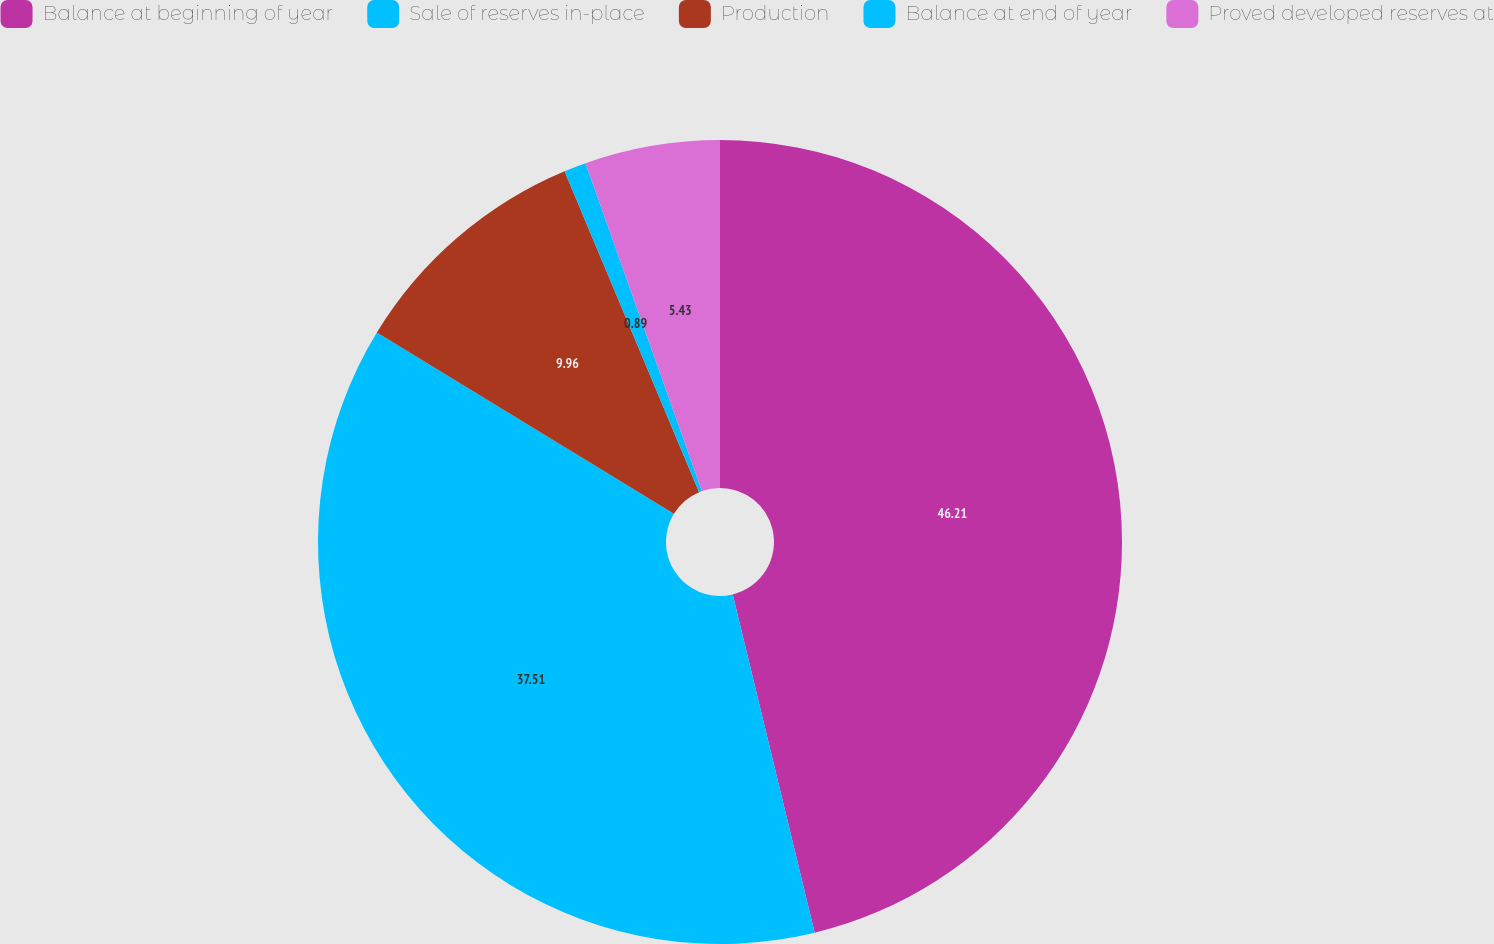Convert chart to OTSL. <chart><loc_0><loc_0><loc_500><loc_500><pie_chart><fcel>Balance at beginning of year<fcel>Sale of reserves in-place<fcel>Production<fcel>Balance at end of year<fcel>Proved developed reserves at<nl><fcel>46.22%<fcel>37.51%<fcel>9.96%<fcel>0.89%<fcel>5.43%<nl></chart> 